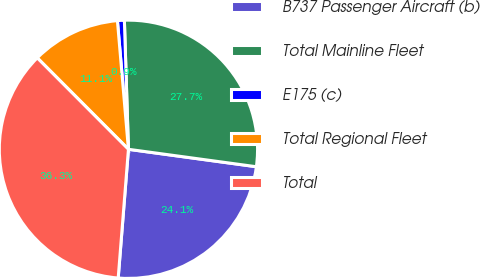Convert chart. <chart><loc_0><loc_0><loc_500><loc_500><pie_chart><fcel>B737 Passenger Aircraft (b)<fcel>Total Mainline Fleet<fcel>E175 (c)<fcel>Total Regional Fleet<fcel>Total<nl><fcel>24.11%<fcel>27.66%<fcel>0.86%<fcel>11.12%<fcel>36.26%<nl></chart> 